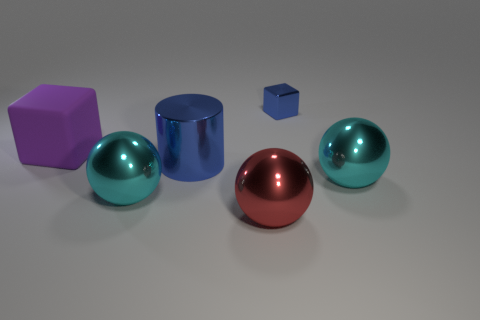There is a rubber thing that is in front of the metal cube; is its shape the same as the tiny object?
Give a very brief answer. Yes. There is a blue thing behind the large purple thing; what is it made of?
Your response must be concise. Metal. There is a large cyan thing to the right of the blue metallic thing that is to the right of the blue metallic cylinder; what is its shape?
Your response must be concise. Sphere. There is a large red thing; is its shape the same as the blue metallic object that is in front of the purple block?
Your answer should be compact. No. There is a big cyan thing that is right of the big red ball; what number of big cyan objects are left of it?
Offer a very short reply. 1. There is another purple object that is the same shape as the tiny thing; what is its material?
Offer a terse response. Rubber. What number of blue things are either small balls or balls?
Offer a very short reply. 0. Is there anything else of the same color as the metallic cylinder?
Give a very brief answer. Yes. There is a big shiny object in front of the cyan shiny thing that is left of the cylinder; what is its color?
Your answer should be very brief. Red. Is the number of blue cubes that are behind the small metallic cube less than the number of red shiny things that are behind the cylinder?
Your answer should be very brief. No. 